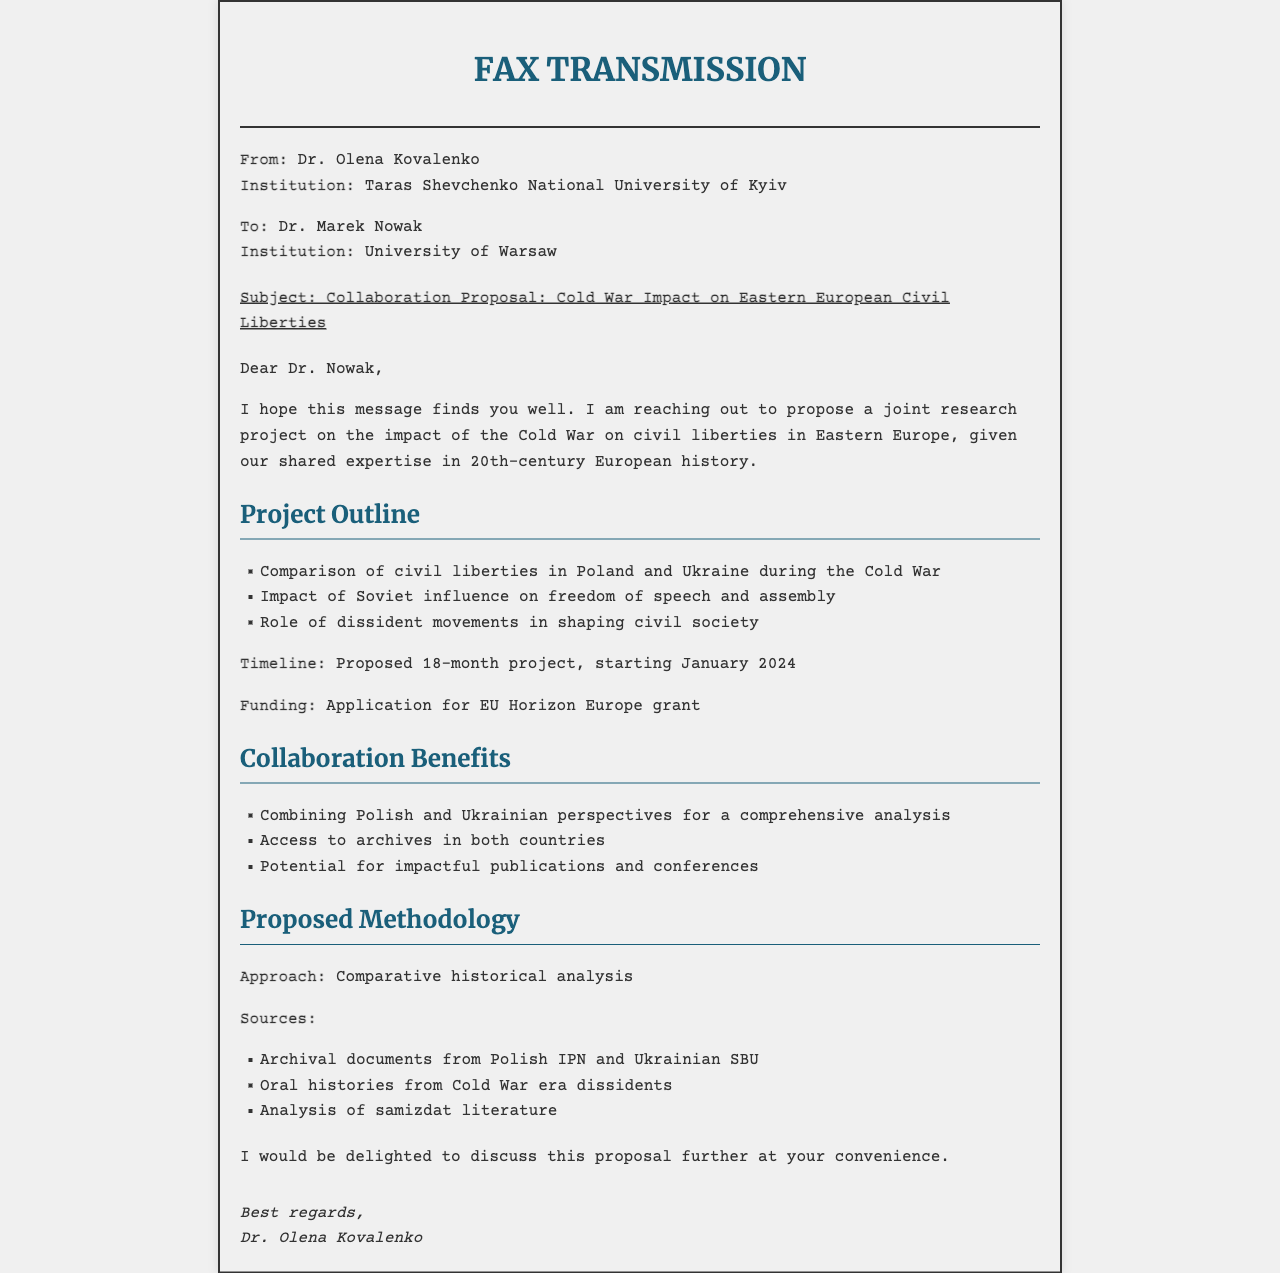What is the sender's name? The sender's name is listed in the document as Dr. Olena Kovalenko.
Answer: Dr. Olena Kovalenko What is the recipient's institution? The recipient's institution is provided in the document as the University of Warsaw.
Answer: University of Warsaw What is the subject of the fax? The subject of the fax clearly states the collaboration proposal regarding the Cold War's impact on Eastern European civil liberties.
Answer: Collaboration Proposal: Cold War Impact on Eastern European Civil Liberties What is the proposed project timeline? The document suggests a timeline for the project, specifically noting the start date and duration.
Answer: 18-month project, starting January 2024 What are the sources proposed for the research? The document lists specific types of sources that will be used in the proposed study.
Answer: Archival documents from Polish IPN and Ukrainian SBU, Oral histories from Cold War era dissidents, Analysis of samizdat literature What is one benefit of the collaboration mentioned? The benefits section highlights several advantages of the proposed collaboration, which can be captured in a single phrase.
Answer: Combining Polish and Ukrainian perspectives for a comprehensive analysis What methodology is proposed for the research? The document specifies the methodological approach to be taken for the research project.
Answer: Comparative historical analysis How many points are listed under the project outline? The number of points in the project outline section is clear from the content shown.
Answer: Three points 